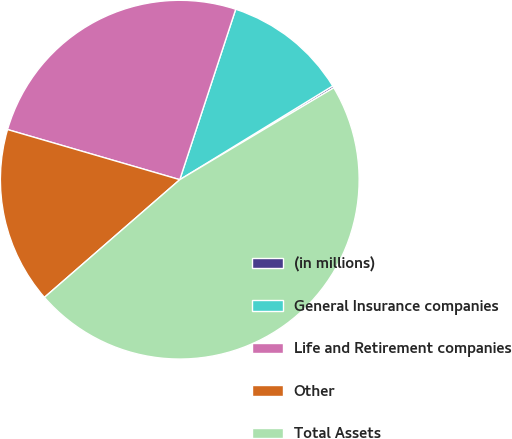<chart> <loc_0><loc_0><loc_500><loc_500><pie_chart><fcel>(in millions)<fcel>General Insurance companies<fcel>Life and Retirement companies<fcel>Other<fcel>Total Assets<nl><fcel>0.19%<fcel>11.2%<fcel>25.54%<fcel>15.9%<fcel>47.17%<nl></chart> 